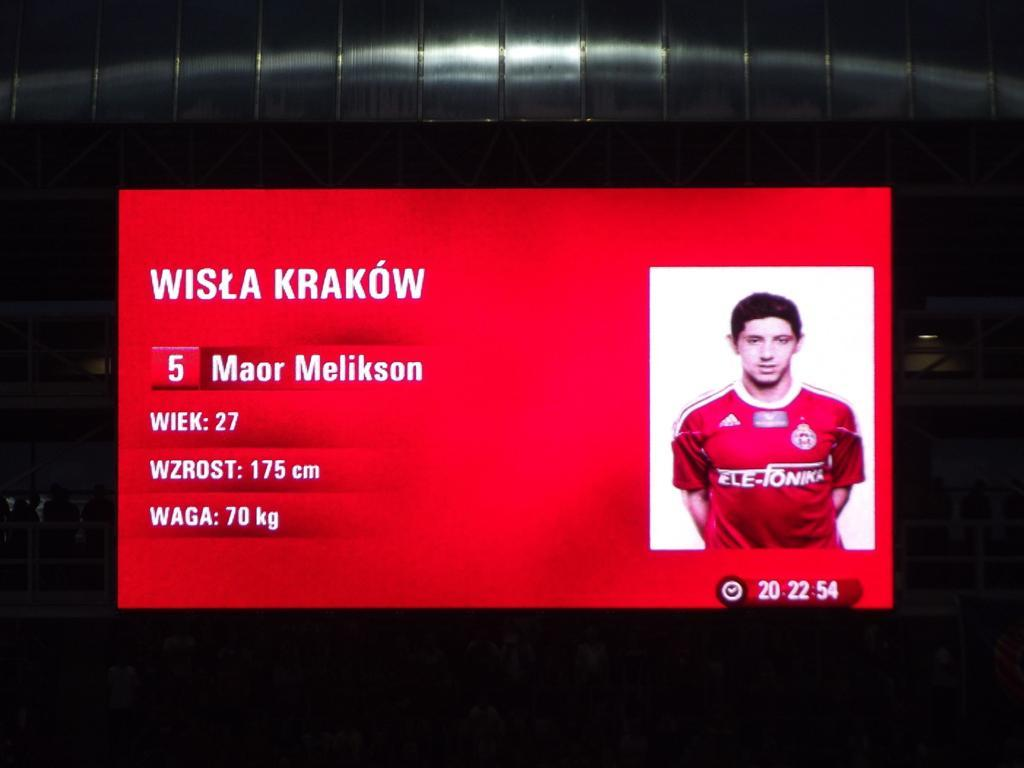Provide a one-sentence caption for the provided image. Player number 5's photo and weight are shown on a red background. 